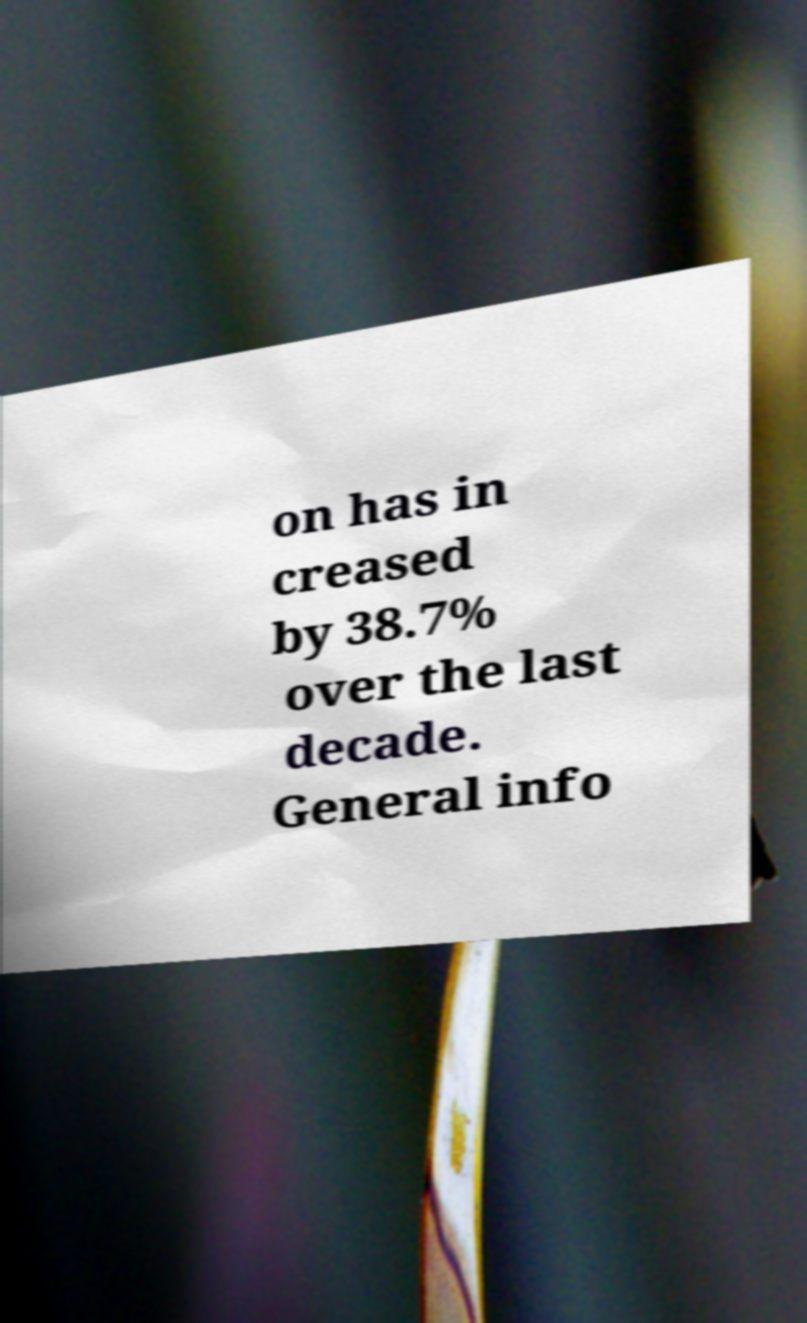Can you read and provide the text displayed in the image?This photo seems to have some interesting text. Can you extract and type it out for me? on has in creased by 38.7% over the last decade. General info 